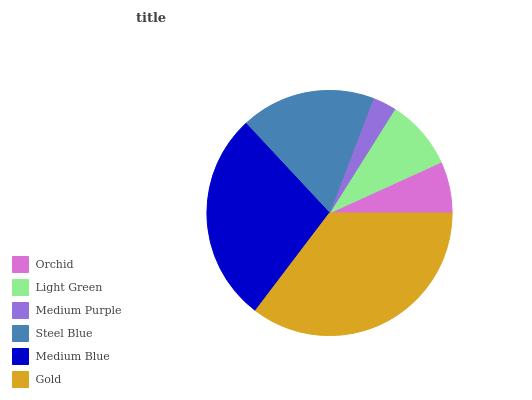Is Medium Purple the minimum?
Answer yes or no. Yes. Is Gold the maximum?
Answer yes or no. Yes. Is Light Green the minimum?
Answer yes or no. No. Is Light Green the maximum?
Answer yes or no. No. Is Light Green greater than Orchid?
Answer yes or no. Yes. Is Orchid less than Light Green?
Answer yes or no. Yes. Is Orchid greater than Light Green?
Answer yes or no. No. Is Light Green less than Orchid?
Answer yes or no. No. Is Steel Blue the high median?
Answer yes or no. Yes. Is Light Green the low median?
Answer yes or no. Yes. Is Gold the high median?
Answer yes or no. No. Is Gold the low median?
Answer yes or no. No. 